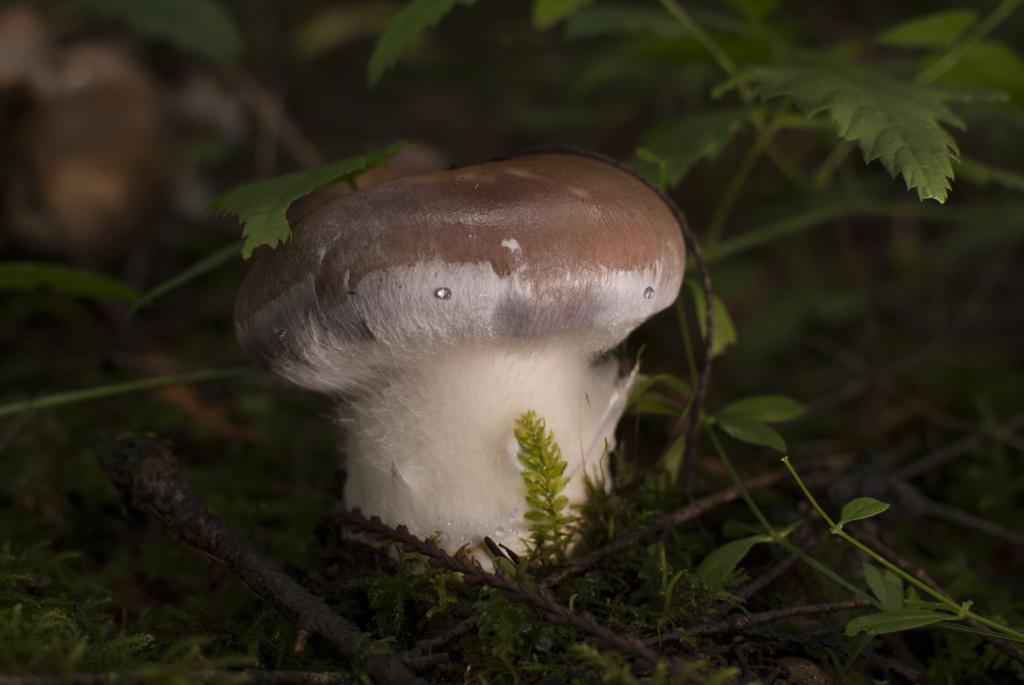What is the main subject of the image? There is a mushroom in the image. What else can be seen in the image besides the mushroom? There are leaves in the image. How are the leaves positioned in relation to the mushroom? The leaves are around the mushroom. Where is the store located in the image? There is no store present in the image; it features a mushroom and leaves. What type of throne is depicted in the image? There is no throne present in the image; it features a mushroom and leaves. 